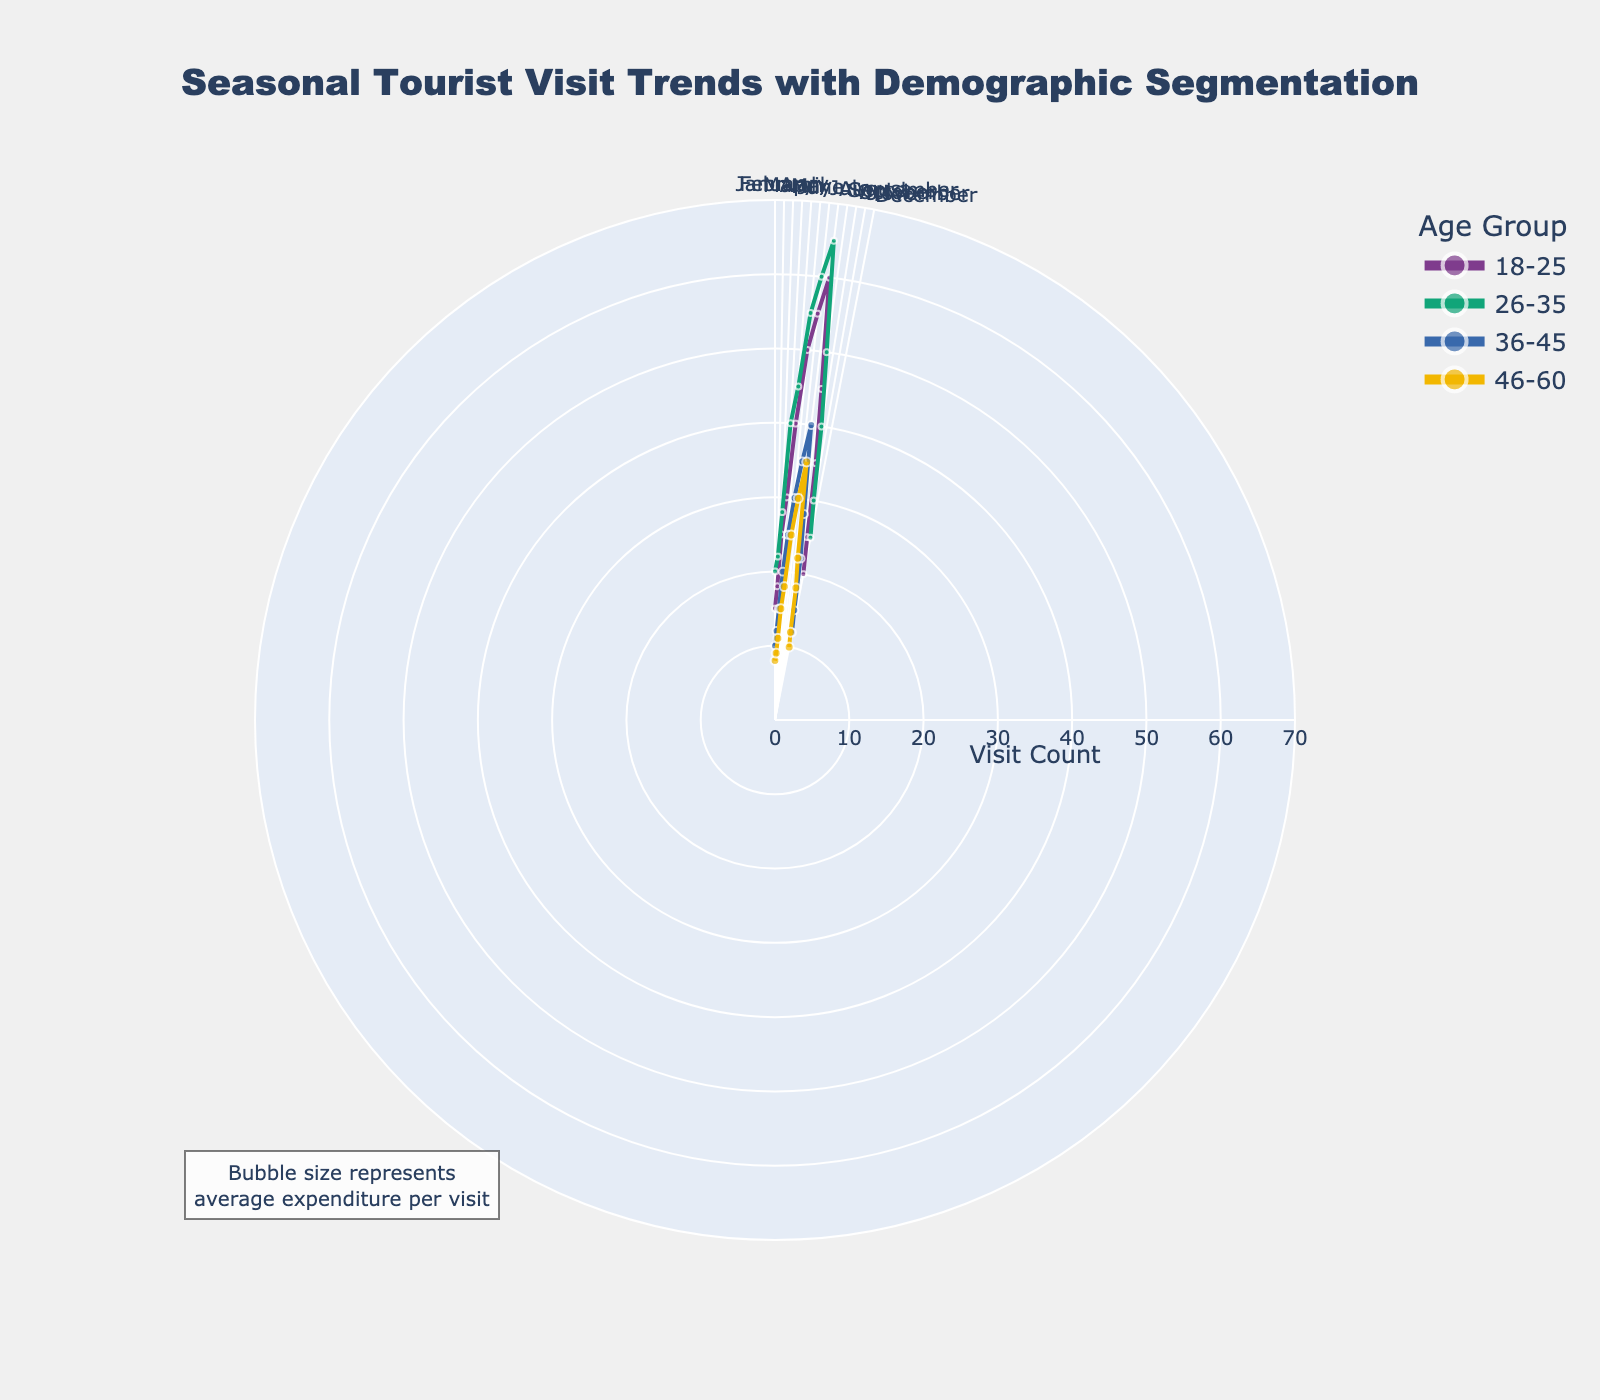What's the title of the figure? The title is usually displayed at the top of a figure, often with larger and bold text. In this chart, the title is "Seasonal Tourist Visit Trends with Demographic Segmentation."
Answer: Seasonal Tourist Visit Trends with Demographic Segmentation How are the months represented on the chart? The months are represented on the angular axis (circular part) of the polar chart. Each tick corresponds to a month in a clockwise direction, starting from "January."
Answer: Radially in a clockwise direction Which age group had the highest number of visits in July? To determine the highest number of visits, look at the radial distance (r) for the month of July for each age group. The data points for the age group "26-35" has the highest radial distance, representing the most visits.
Answer: 26-35 What's the bubble size representation in the chart? The annotation at the bottom left of the figure states that bubble size represents the average expenditure per visit.
Answer: Average expenditure per visit During which month did the age group 18-25 have the lowest average expenditure? Hover over or look at the bubble sizes for the age group "18-25" across all months. The smallest bubble for this group appears in February.
Answer: February Compare the visit counts between the age groups 18-25 and 46-60 for August. Which group had more visits? Examine the radial distances for the age groups "18-25" and "46-60" in August. The "18-25" group has a greater radial length, indicating more visits.
Answer: 18-25 How does the average expenditure for the 36-45 age group in June compare to that in December? Compare the bubble sizes for the "36-45" age group between June and December. The bubble in June is larger compared to the one in December, indicating higher average expenditure.
Answer: Higher in June Which age group had the increasing trend in visit count from January to August? Look at the lines connecting the data points from January to August for each age group. The line for the "26-35" group shows a consistent upward trend.
Answer: 26-35 What is the general trend in tourist visits for all age groups during summer months (June-August)? Summarize the radial positions of data points for all age groups during the summer months. All age groups have increasing visit counts during these months, indicated by larger radial distances.
Answer: Increasing trend In which month and age group was the increase in visit count the highest from the previous month? Compare the increments in radial distances (r) month by month for each age group. The largest increase is seen from May to June for the 18-25 age group.
Answer: 18-25 in June 